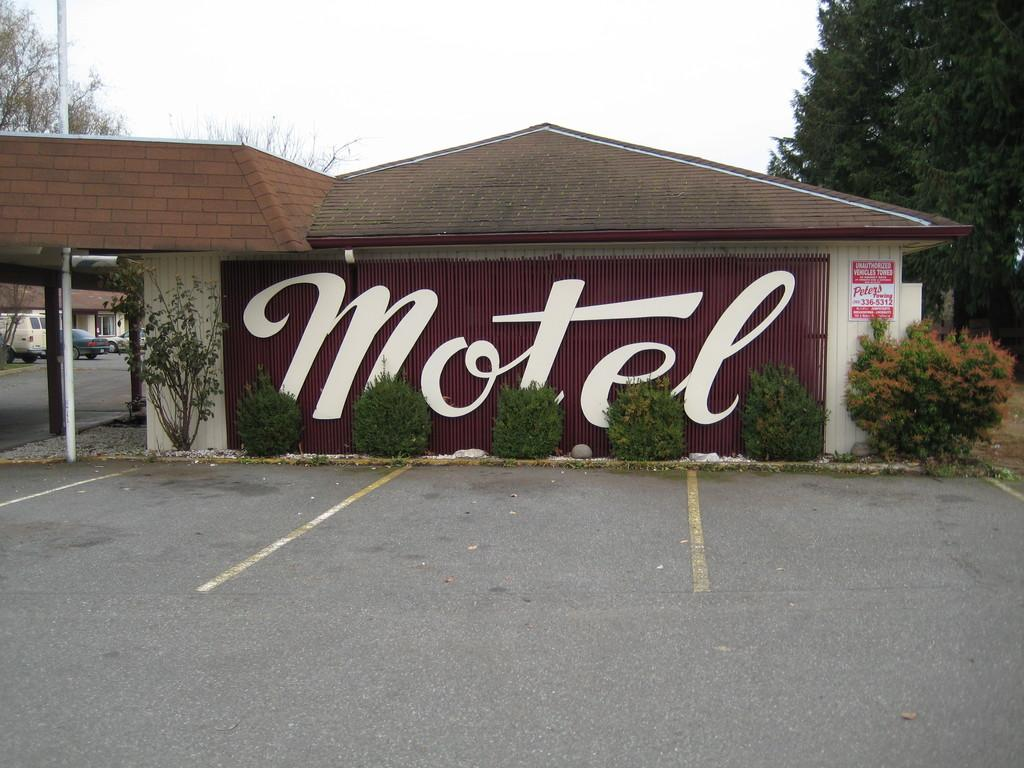Where was the image taken? The image was clicked outside. What is the main subject in the middle of the image? There is a building in the middle of the image. What type of vegetation can be seen on the left side of the image? There are trees on the left side of the image. What type of vegetation can be seen on the right side of the image? There are trees on the right side of the image. What else is present in the middle of the image besides the building? There are bushes in the middle of the image. What type of vehicles can be seen on the left side of the image? There are cars on the left side of the image. What time of day is it in the image, considering the presence of the night? The image does not depict nighttime; it was taken outside during the day, as indicated by the presence of sunlight. What type of animal can be seen with fangs in the image? There are no animals with fangs present in the image. 